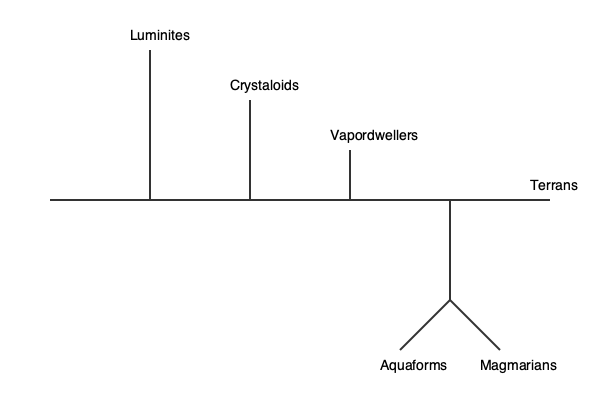In the science fiction novel "Galactic Biome," analyze the evolutionary relationships depicted in the provided phylogenetic tree. Which species appears to be the most closely related to Terrans, and what literary implications might this have for the novel's themes of biology and evolution? To analyze the evolutionary relationships and their literary implications, we need to follow these steps:

1. Examine the structure of the phylogenetic tree:
   The tree shows six species: Luminites, Crystaloids, Vapordwellers, Terrans, Aquaforms, and Magmarians.

2. Identify the branching patterns:
   - Luminites branch off earliest
   - Crystaloids branch off second
   - Vapordwellers branch off third
   - Terrans are at the end of the main branch
   - Aquaforms and Magmarians share a common ancestor that branched off from the main line

3. Determine the closest relative to Terrans:
   Based on the tree, Vapordwellers are the most closely related to Terrans, as they share the most recent common ancestor.

4. Analyze the literary implications:
   a) Evolutionary proximity: The close relationship between Terrans and Vapordwellers suggests potential similarities in their biology or adaptations.
   b) Thematic exploration: This relationship could be used to explore themes of environmental adaptation, as Vapordwellers likely evolved to inhabit gaseous environments.
   c) Character interactions: The author might use this evolutionary link to create more nuanced interactions or conflicts between Terrans and Vapordwellers.
   d) Biological speculations: The novel could delve into how two closely related species evolved to inhabit such different environments (solid planet vs. gaseous habitat).
   e) Evolutionary narrative: The tree structure allows for a discussion of the evolutionary history of all species, potentially tying into the novel's larger themes about the development of life in the galaxy.

5. Consider the other species:
   The early branching of Luminites and Crystaloids could represent more alien or exotic life forms, potentially allowing for exploration of extreme biological diversity.

6. Aquaforms and Magmarians:
   These species' shared ancestry but divergent environments (likely water and magma) could be used to discuss concepts of adaptive radiation and convergent evolution in the narrative.

By analyzing this evolutionary tree, the novel can weave together themes of biological diversity, environmental adaptation, and the interconnectedness of life, even across vast galactic distances and diverse habitats.
Answer: Vapordwellers; allows exploration of adaptive evolution and interspecies relationships. 